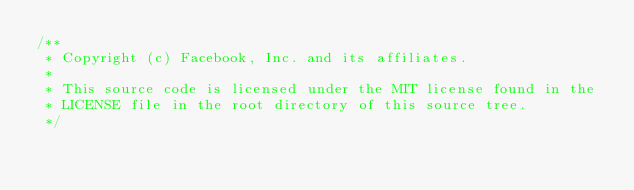<code> <loc_0><loc_0><loc_500><loc_500><_ObjectiveC_>/**
 * Copyright (c) Facebook, Inc. and its affiliates.
 *
 * This source code is licensed under the MIT license found in the
 * LICENSE file in the root directory of this source tree.
 */
</code> 